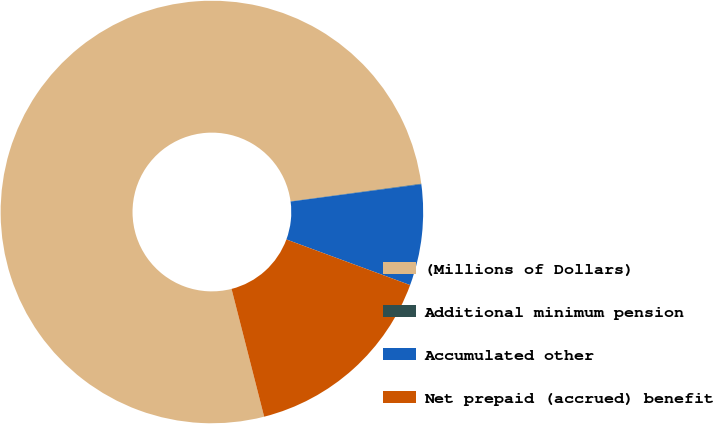Convert chart. <chart><loc_0><loc_0><loc_500><loc_500><pie_chart><fcel>(Millions of Dollars)<fcel>Additional minimum pension<fcel>Accumulated other<fcel>Net prepaid (accrued) benefit<nl><fcel>76.84%<fcel>0.04%<fcel>7.72%<fcel>15.4%<nl></chart> 